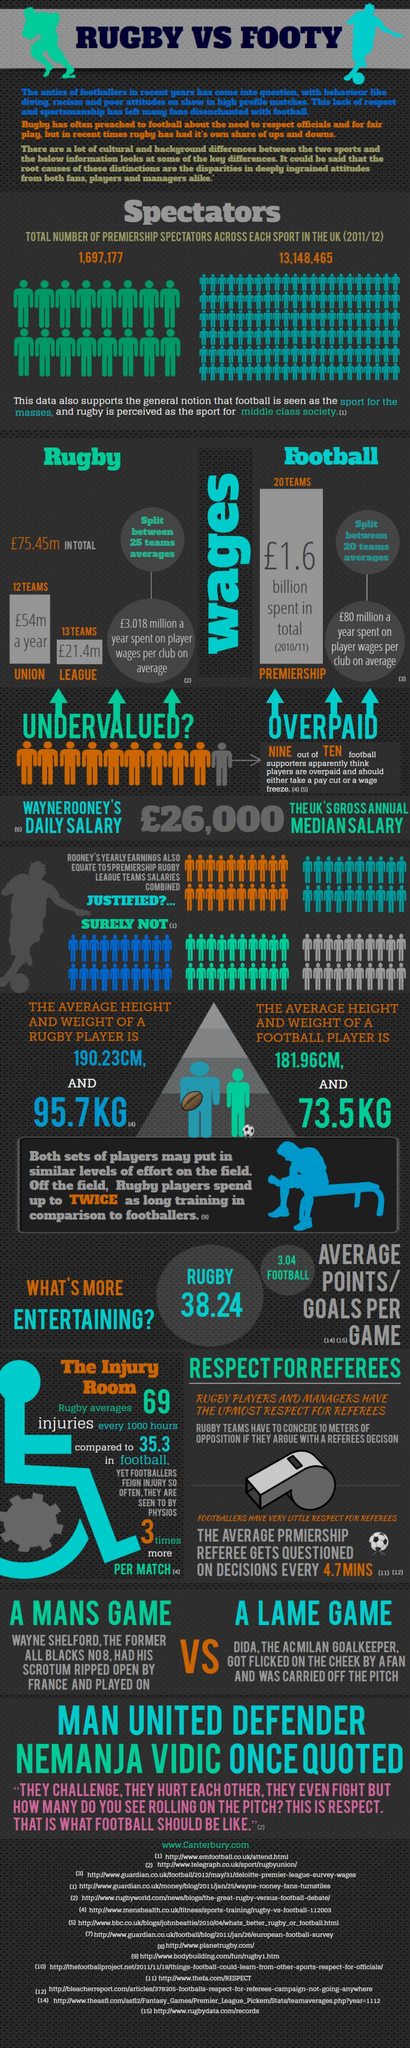What is is the average weight of rugby player, 190.2 kg, 95.7 kg, or 73.5 kg?
Answer the question with a short phrase. 95.7kg Which sport had the most number of spectators in 2011-12 in UK, Rugby, Football, or Cricket? Football 